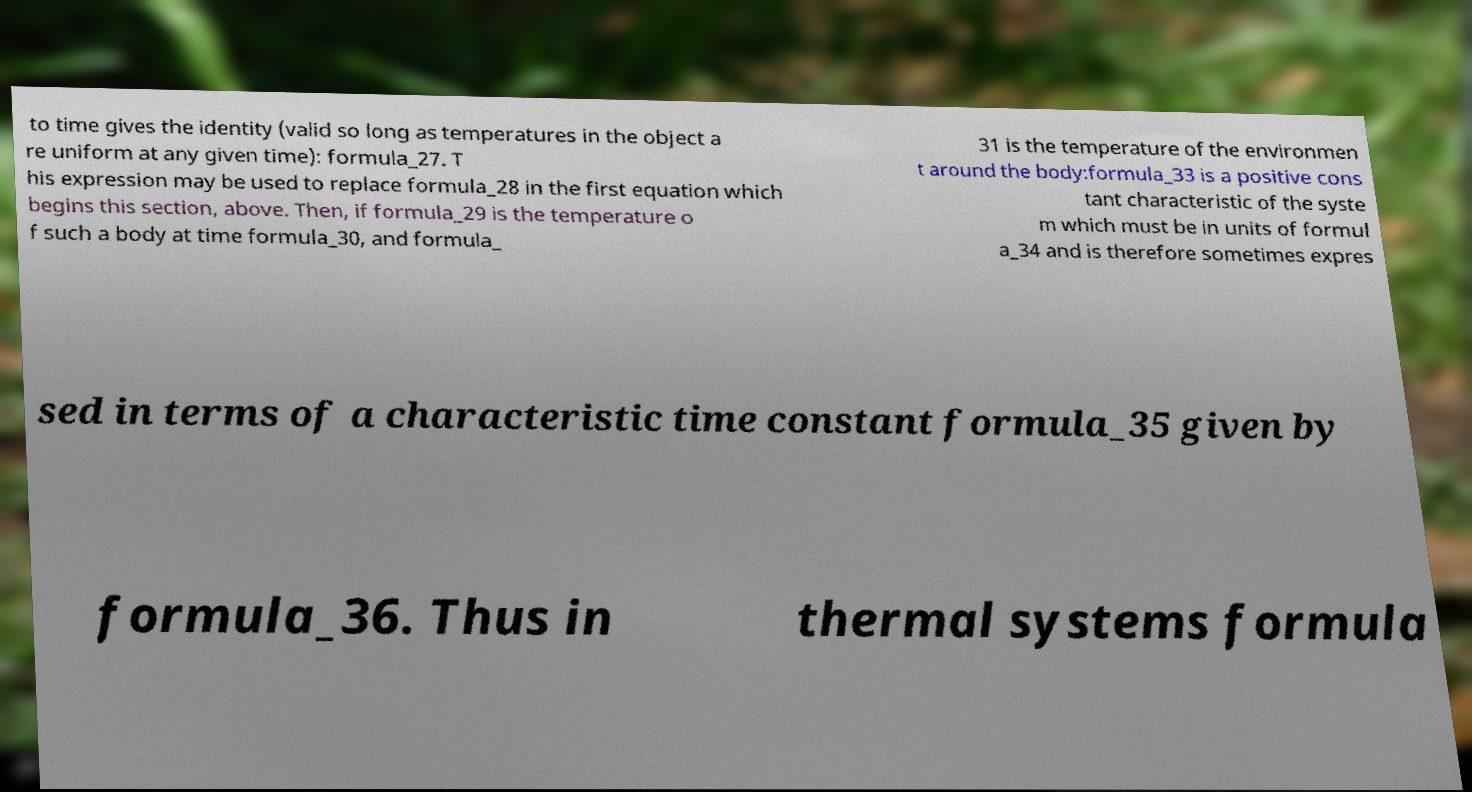Could you assist in decoding the text presented in this image and type it out clearly? to time gives the identity (valid so long as temperatures in the object a re uniform at any given time): formula_27. T his expression may be used to replace formula_28 in the first equation which begins this section, above. Then, if formula_29 is the temperature o f such a body at time formula_30, and formula_ 31 is the temperature of the environmen t around the body:formula_33 is a positive cons tant characteristic of the syste m which must be in units of formul a_34 and is therefore sometimes expres sed in terms of a characteristic time constant formula_35 given by formula_36. Thus in thermal systems formula 